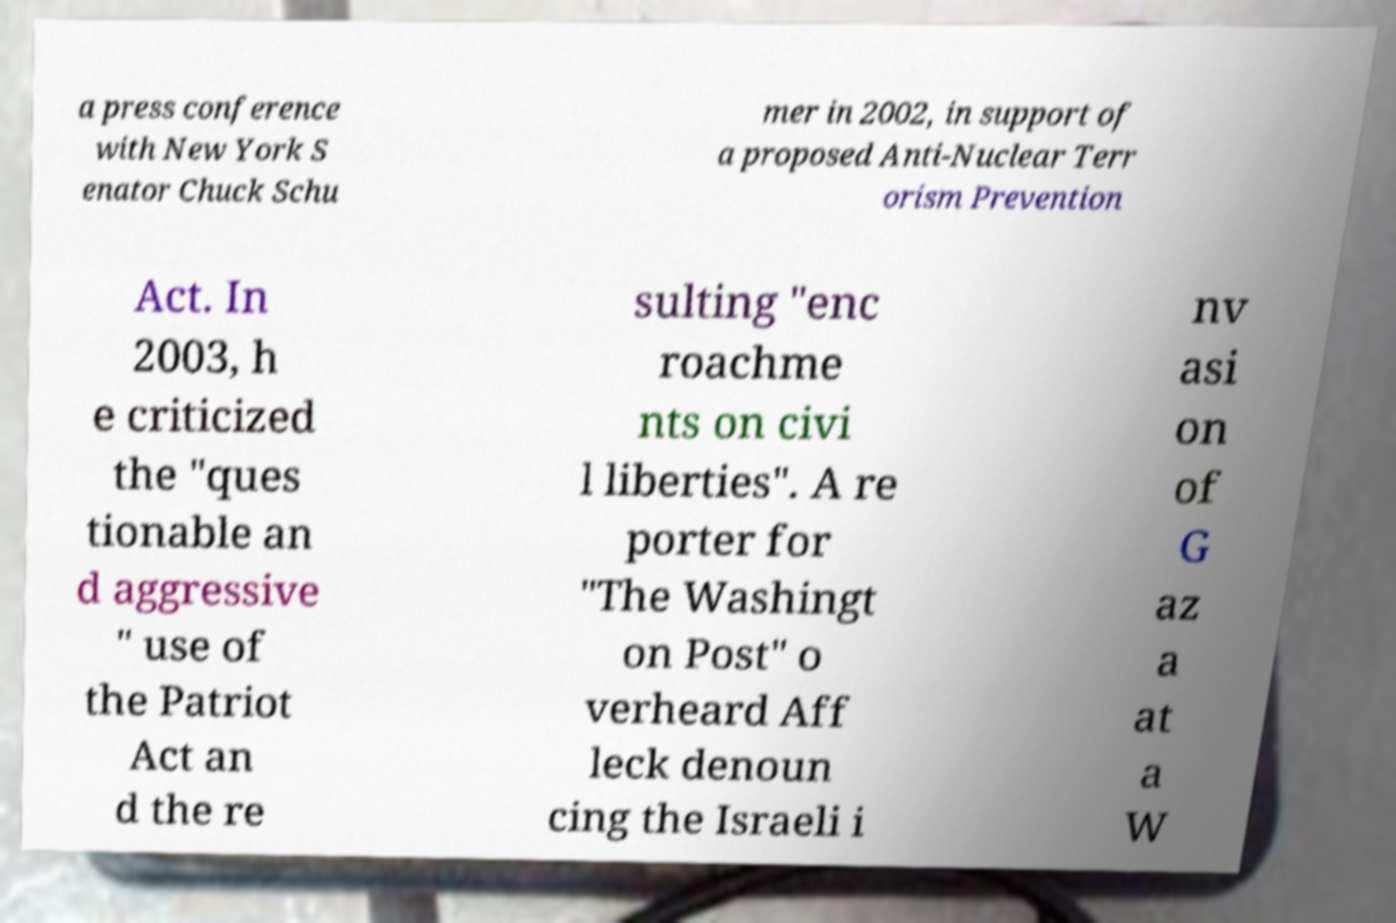Can you read and provide the text displayed in the image?This photo seems to have some interesting text. Can you extract and type it out for me? a press conference with New York S enator Chuck Schu mer in 2002, in support of a proposed Anti-Nuclear Terr orism Prevention Act. In 2003, h e criticized the "ques tionable an d aggressive " use of the Patriot Act an d the re sulting "enc roachme nts on civi l liberties". A re porter for "The Washingt on Post" o verheard Aff leck denoun cing the Israeli i nv asi on of G az a at a W 